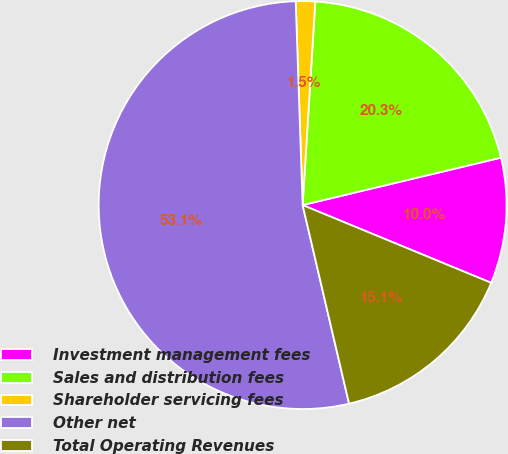Convert chart. <chart><loc_0><loc_0><loc_500><loc_500><pie_chart><fcel>Investment management fees<fcel>Sales and distribution fees<fcel>Shareholder servicing fees<fcel>Other net<fcel>Total Operating Revenues<nl><fcel>9.96%<fcel>20.28%<fcel>1.53%<fcel>53.12%<fcel>15.12%<nl></chart> 